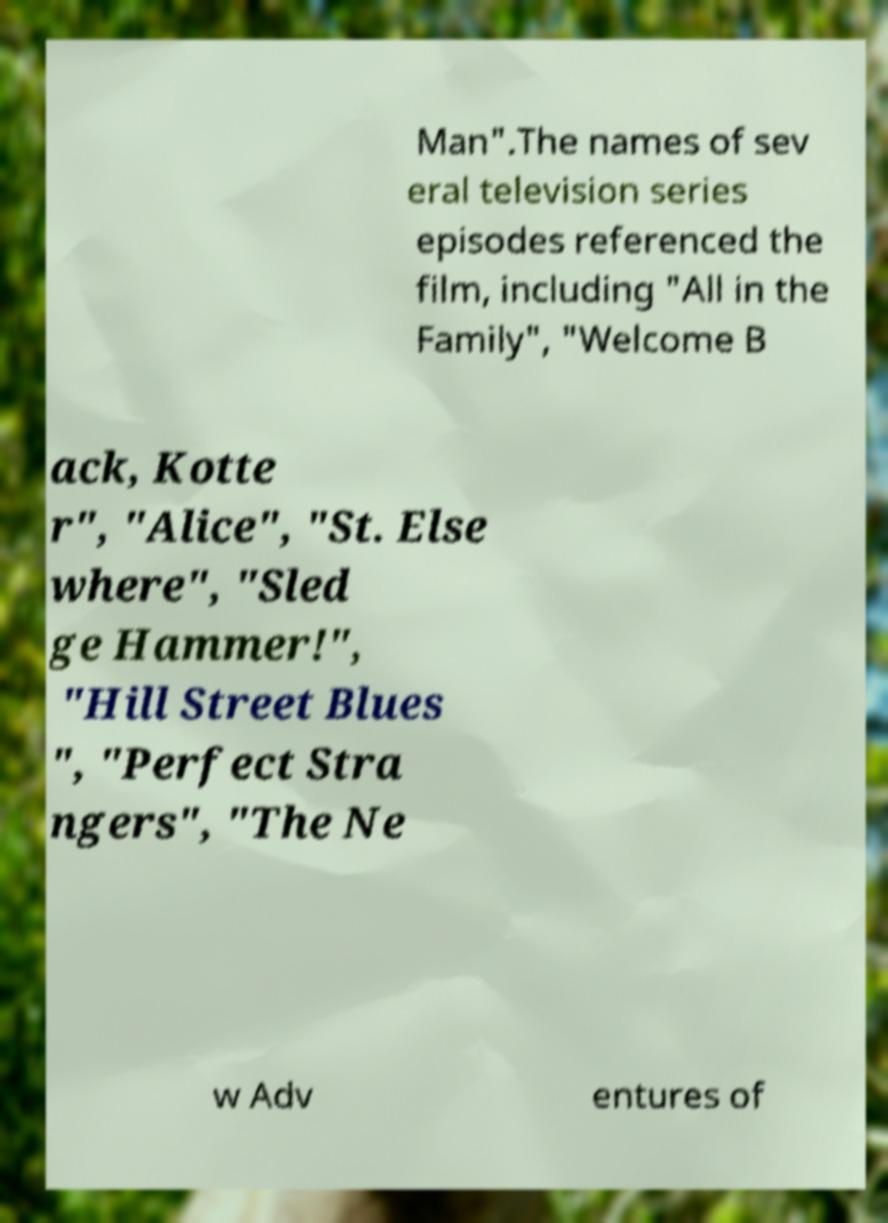Could you extract and type out the text from this image? Man".The names of sev eral television series episodes referenced the film, including "All in the Family", "Welcome B ack, Kotte r", "Alice", "St. Else where", "Sled ge Hammer!", "Hill Street Blues ", "Perfect Stra ngers", "The Ne w Adv entures of 